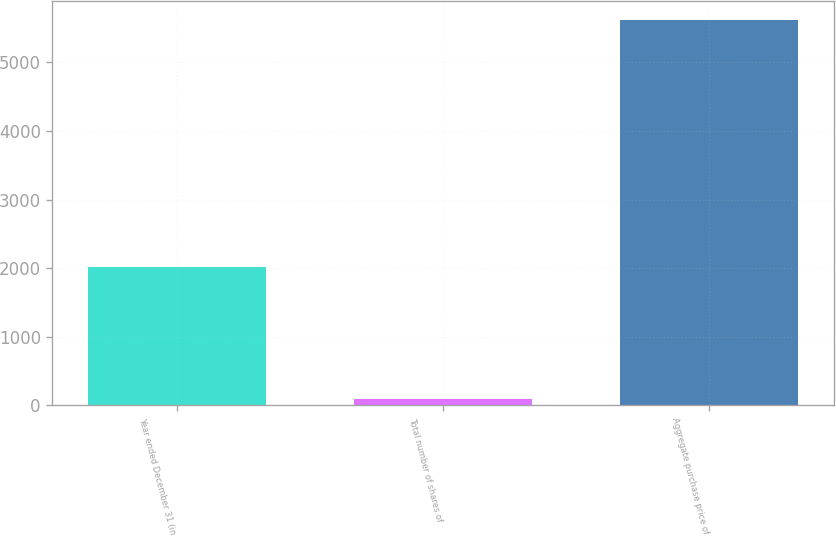<chart> <loc_0><loc_0><loc_500><loc_500><bar_chart><fcel>Year ended December 31 (in<fcel>Total number of shares of<fcel>Aggregate purchase price of<nl><fcel>2015<fcel>89.8<fcel>5616<nl></chart> 